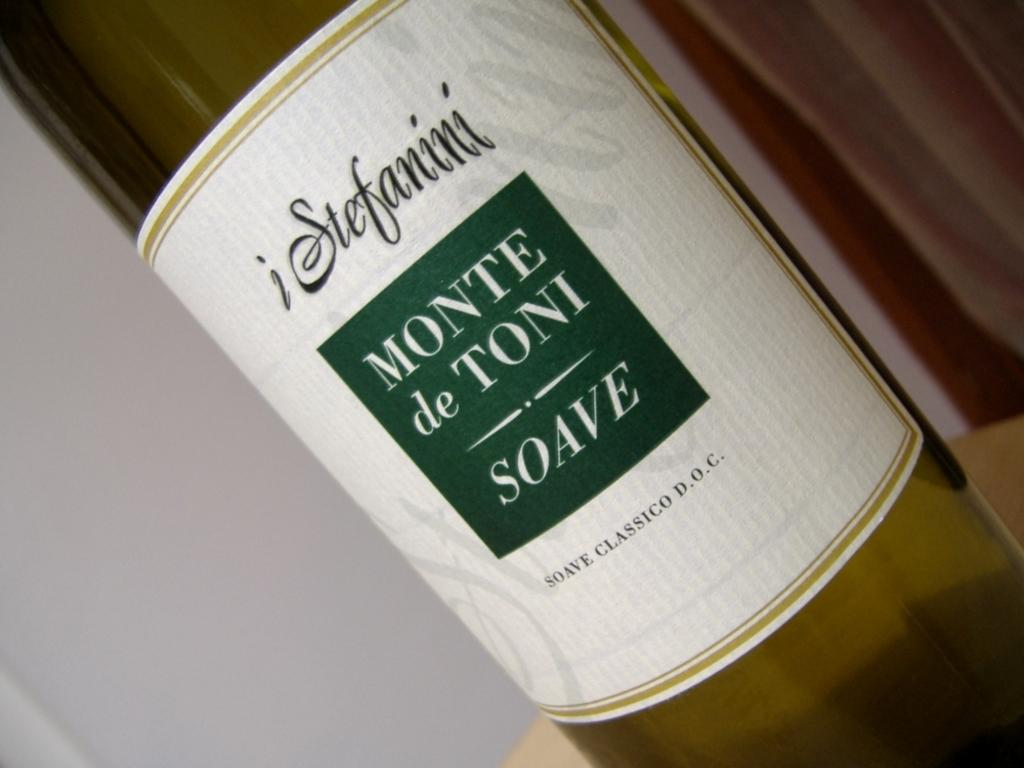<image>
Summarize the visual content of the image. A close up of a bottle of Monte de Toni soave 